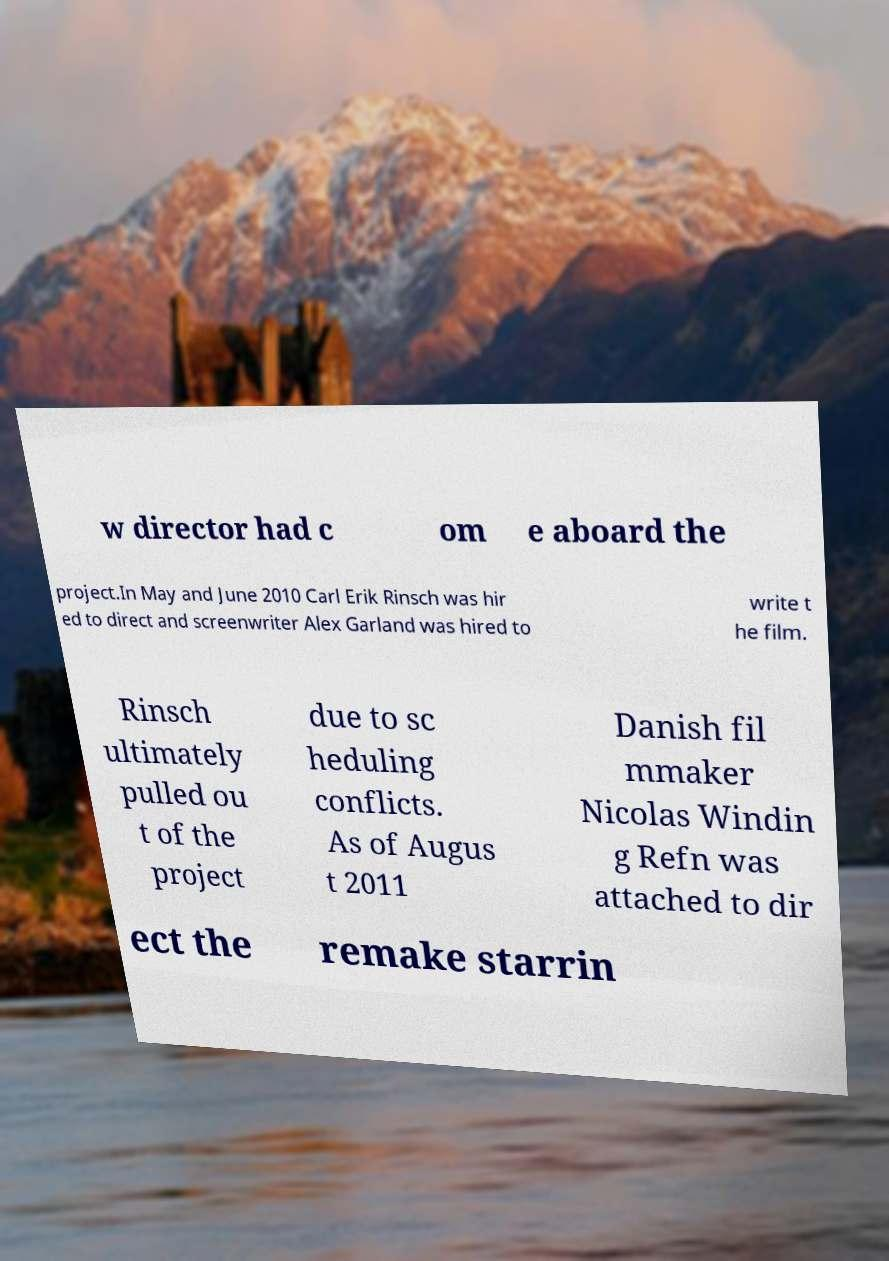Could you extract and type out the text from this image? w director had c om e aboard the project.In May and June 2010 Carl Erik Rinsch was hir ed to direct and screenwriter Alex Garland was hired to write t he film. Rinsch ultimately pulled ou t of the project due to sc heduling conflicts. As of Augus t 2011 Danish fil mmaker Nicolas Windin g Refn was attached to dir ect the remake starrin 